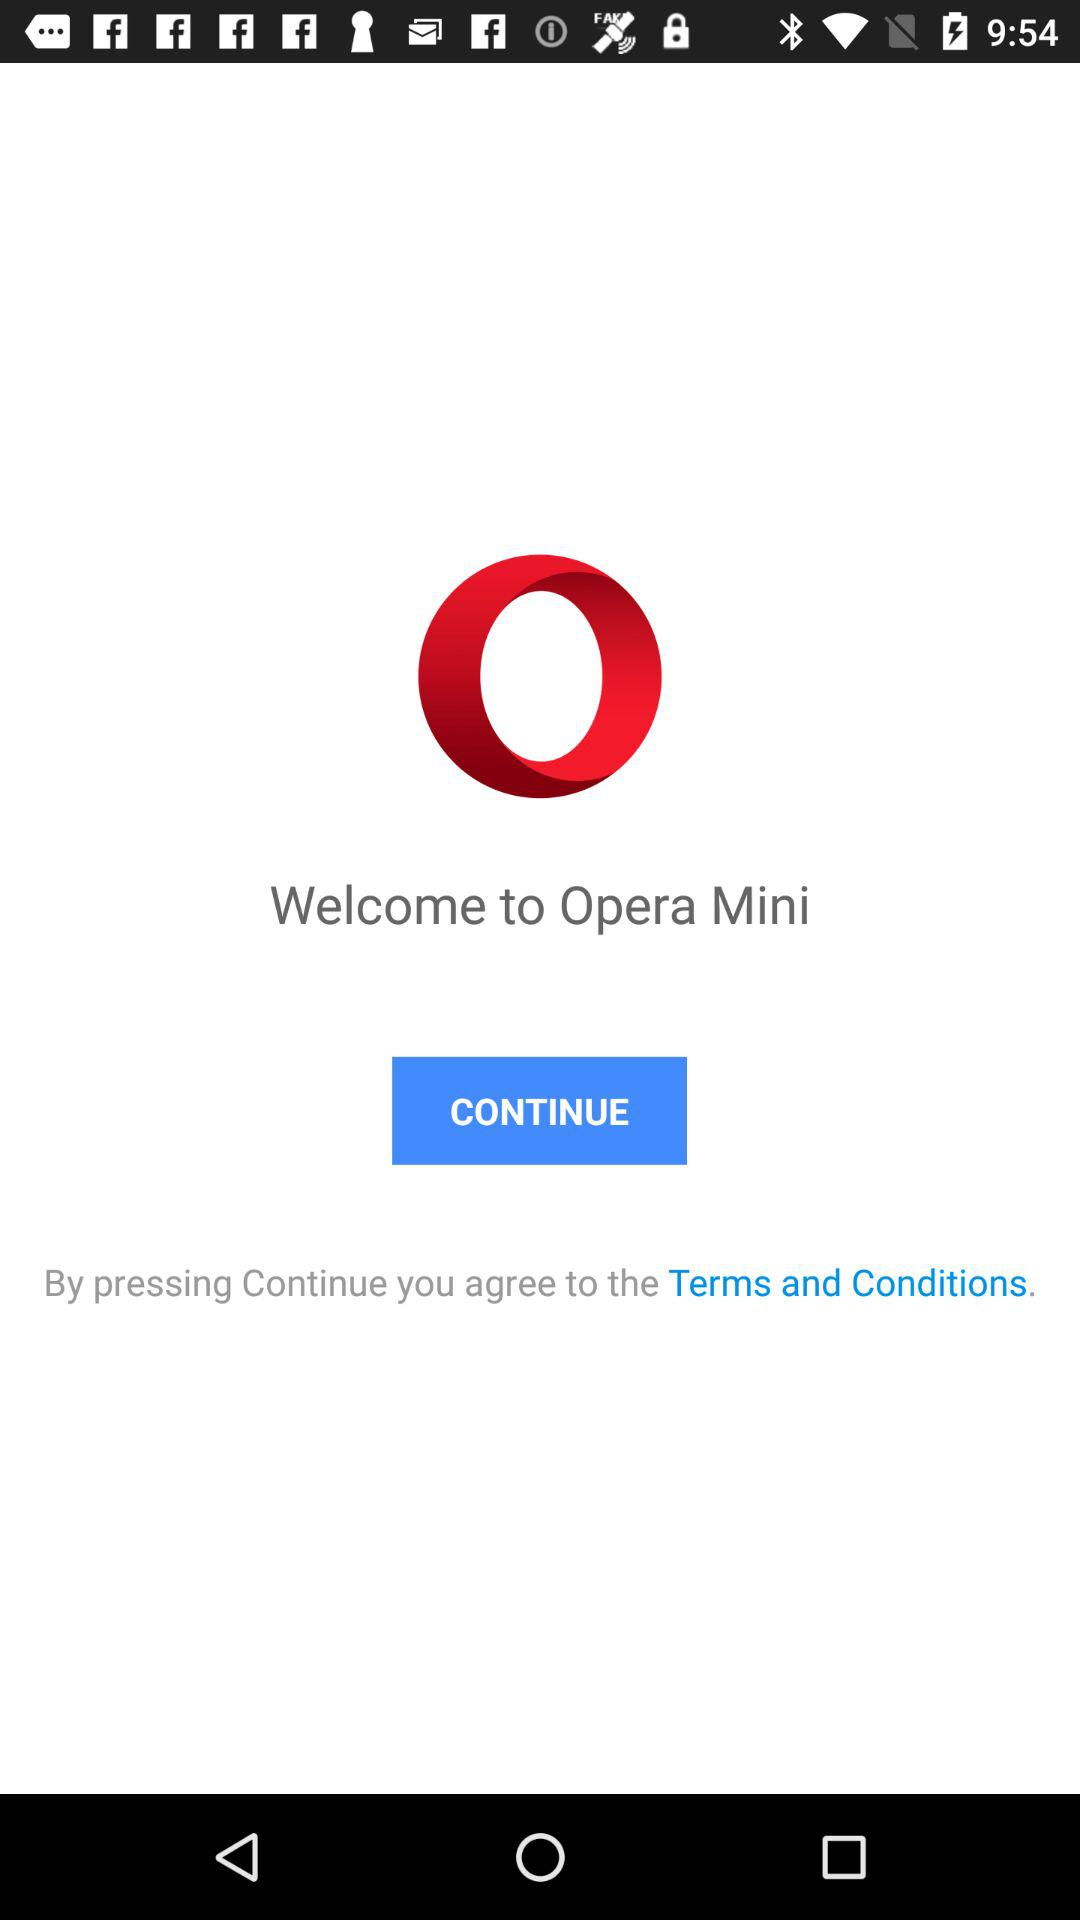What application is it? The application is "Opera Mini". 